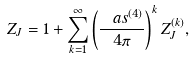<formula> <loc_0><loc_0><loc_500><loc_500>Z _ { J } = 1 + \sum _ { k = 1 } ^ { \infty } \left ( \frac { \ a s ^ { ( 4 ) } } { 4 \pi } \right ) ^ { k } Z _ { J } ^ { ( k ) } ,</formula> 